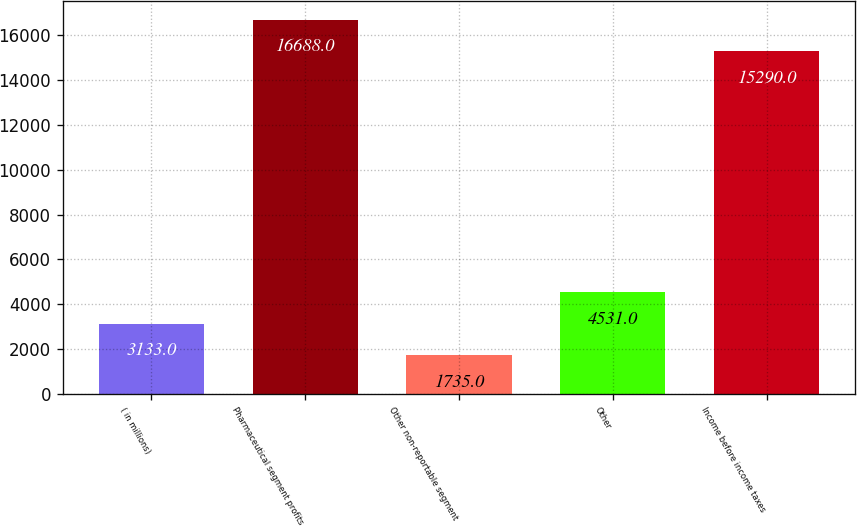Convert chart to OTSL. <chart><loc_0><loc_0><loc_500><loc_500><bar_chart><fcel>( in millions)<fcel>Pharmaceutical segment profits<fcel>Other non-reportable segment<fcel>Other<fcel>Income before income taxes<nl><fcel>3133<fcel>16688<fcel>1735<fcel>4531<fcel>15290<nl></chart> 